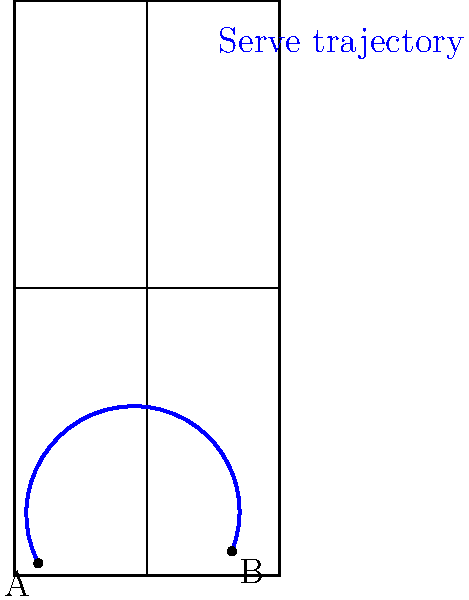Considérez un service de tennis où la balle est frappée du point A et atterrit au point B sur le court de doubles, comme illustré dans le diagramme. Si la vitesse initiale du service est de 180 km/h et l'angle initial est de 5 degrés au-dessus de l'horizontale, quelle est la hauteur maximale atteinte par la balle pendant sa trajectoire, en mètres ? (Négligez la résistance de l'air et supposez que g = 9,8 m/s²) Pour résoudre ce problème, suivons ces étapes :

1) Convertissons la vitesse initiale en m/s :
   $180 \text{ km/h} = 180 \times \frac{1000}{3600} = 50 \text{ m/s}$

2) Décomposons la vitesse initiale en composantes horizontale et verticale :
   $v_{0x} = v_0 \cos \theta = 50 \cos 5° = 49.81 \text{ m/s}$
   $v_{0y} = v_0 \sin \theta = 50 \sin 5° = 4.36 \text{ m/s}$

3) Le temps pour atteindre la hauteur maximale est donné par :
   $t_{max} = \frac{v_{0y}}{g} = \frac{4.36}{9.8} = 0.45 \text{ s}$

4) La hauteur maximale est donnée par l'équation :
   $h_{max} = v_{0y}t - \frac{1}{2}gt^2$

5) Substituons les valeurs :
   $h_{max} = 4.36 \times 0.45 - \frac{1}{2} \times 9.8 \times 0.45^2$
   $h_{max} = 1.96 - 0.99 = 0.97 \text{ m}$

Donc, la hauteur maximale atteinte par la balle est d'environ 0,97 mètres.
Answer: 0,97 m 